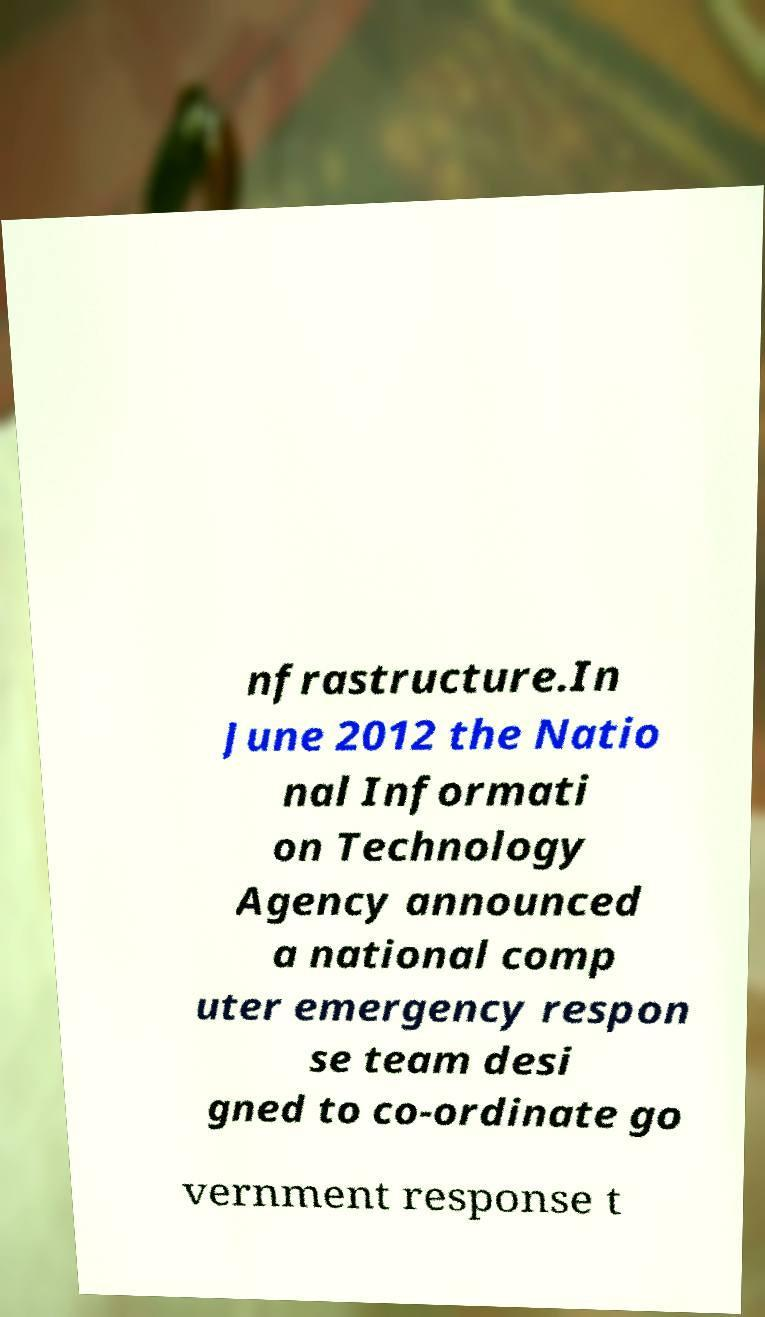What messages or text are displayed in this image? I need them in a readable, typed format. nfrastructure.In June 2012 the Natio nal Informati on Technology Agency announced a national comp uter emergency respon se team desi gned to co-ordinate go vernment response t 